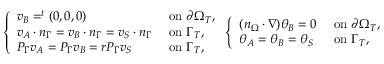Convert formula to latex. <formula><loc_0><loc_0><loc_500><loc_500>\left \{ \begin{array} { l l } { v _ { B } = ^ { t } ( 0 , 0 , 0 ) } & { o n \partial \Omega _ { T } , } \\ { v _ { A } \cdot n _ { \Gamma } = v _ { B } \cdot n _ { \Gamma } = v _ { S } \cdot n _ { \Gamma } } & { o n \Gamma _ { T } , } \\ { P _ { \Gamma } v _ { A } = P _ { \Gamma } v _ { B } = r P _ { \Gamma } v _ { S } } & { o n \Gamma _ { T } , } \end{array} \left \{ \begin{array} { l l } { ( n _ { \Omega } \cdot \nabla ) \theta _ { B } = 0 } & { o n \partial \Omega _ { T } , } \\ { \theta _ { A } = \theta _ { B } = \theta _ { S } } & { o n \Gamma _ { T } , } \end{array}</formula> 